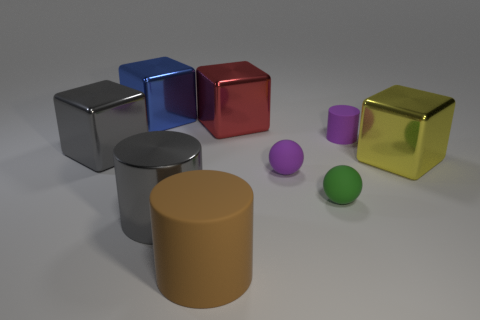The gray thing that is the same size as the gray metal cube is what shape?
Give a very brief answer. Cylinder. Is the color of the big rubber cylinder the same as the rubber ball that is behind the small green thing?
Your response must be concise. No. How many large blocks are to the right of the big metallic cube to the left of the large blue metal block?
Make the answer very short. 3. There is a thing that is left of the brown cylinder and in front of the big yellow block; what is its size?
Your answer should be very brief. Large. Is there a gray rubber block that has the same size as the red object?
Offer a very short reply. No. Are there more tiny purple objects right of the tiny green ball than tiny purple matte objects to the left of the purple ball?
Your answer should be compact. Yes. Is the material of the gray cylinder the same as the large blue block behind the brown matte cylinder?
Offer a very short reply. Yes. How many large gray metal things are to the left of the big metal thing that is in front of the large object that is right of the red shiny cube?
Your answer should be very brief. 1. Do the brown thing and the purple matte thing on the left side of the green ball have the same shape?
Keep it short and to the point. No. The big metal cube that is both to the right of the brown rubber thing and behind the big yellow thing is what color?
Offer a terse response. Red. 